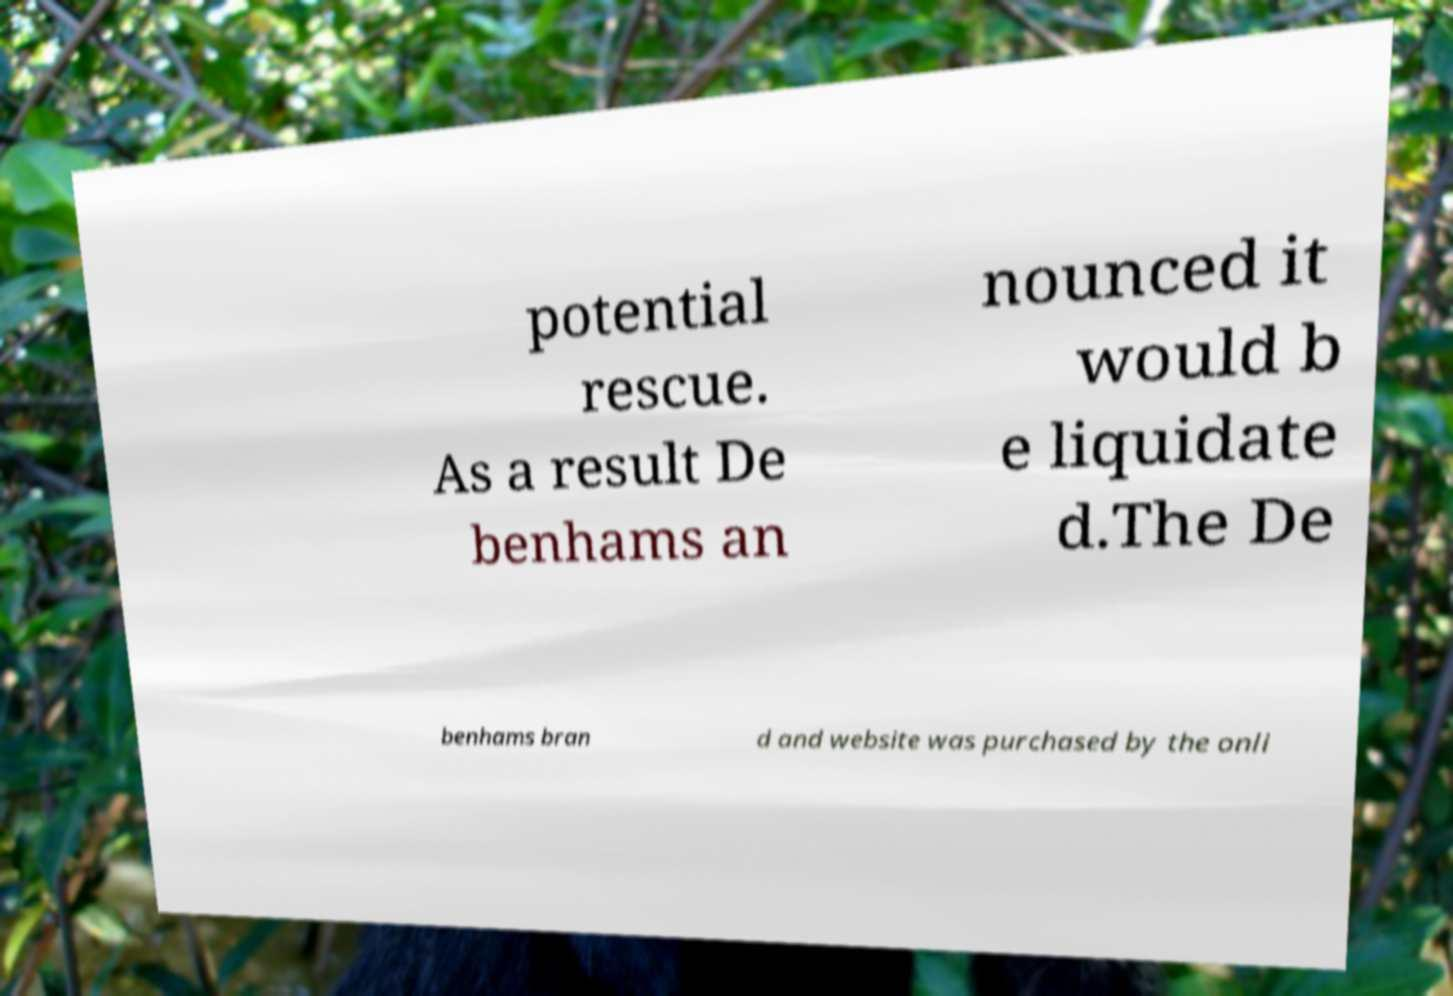I need the written content from this picture converted into text. Can you do that? potential rescue. As a result De benhams an nounced it would b e liquidate d.The De benhams bran d and website was purchased by the onli 